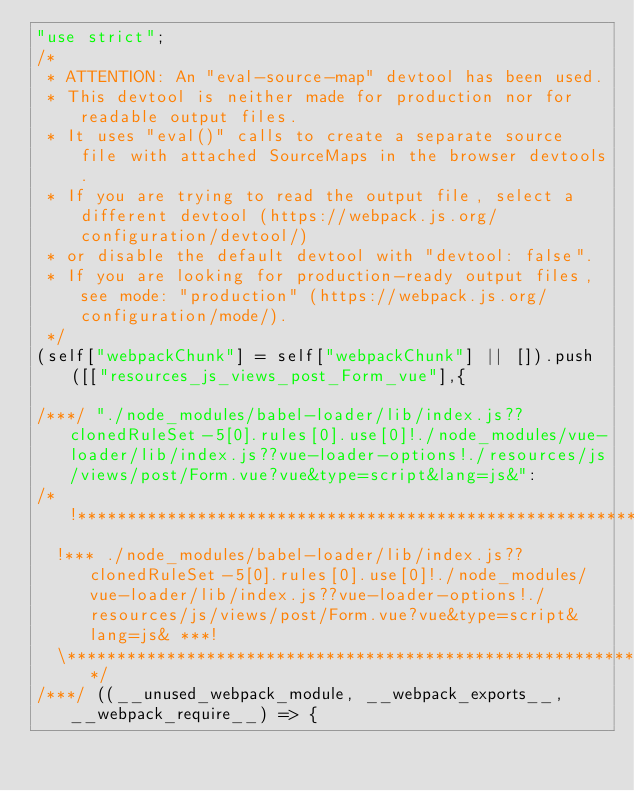<code> <loc_0><loc_0><loc_500><loc_500><_JavaScript_>"use strict";
/*
 * ATTENTION: An "eval-source-map" devtool has been used.
 * This devtool is neither made for production nor for readable output files.
 * It uses "eval()" calls to create a separate source file with attached SourceMaps in the browser devtools.
 * If you are trying to read the output file, select a different devtool (https://webpack.js.org/configuration/devtool/)
 * or disable the default devtool with "devtool: false".
 * If you are looking for production-ready output files, see mode: "production" (https://webpack.js.org/configuration/mode/).
 */
(self["webpackChunk"] = self["webpackChunk"] || []).push([["resources_js_views_post_Form_vue"],{

/***/ "./node_modules/babel-loader/lib/index.js??clonedRuleSet-5[0].rules[0].use[0]!./node_modules/vue-loader/lib/index.js??vue-loader-options!./resources/js/views/post/Form.vue?vue&type=script&lang=js&":
/*!***********************************************************************************************************************************************************************************************************!*\
  !*** ./node_modules/babel-loader/lib/index.js??clonedRuleSet-5[0].rules[0].use[0]!./node_modules/vue-loader/lib/index.js??vue-loader-options!./resources/js/views/post/Form.vue?vue&type=script&lang=js& ***!
  \***********************************************************************************************************************************************************************************************************/
/***/ ((__unused_webpack_module, __webpack_exports__, __webpack_require__) => {
</code> 